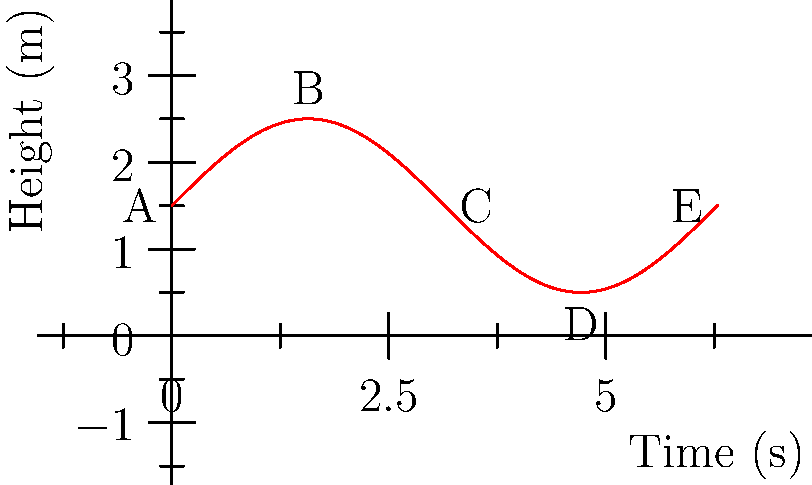In your ballet film, a dancer performs a series of fouetté turns. The graph shows the dancer's height above the stage during one complete turn, modeled by the function $h(t) = 1.5 + \sin(t)$, where $h$ is in meters and $t$ is in seconds. At what point during the turn is the dancer's vertical velocity the greatest, and what is this maximum velocity? To solve this, let's follow these steps:

1) The vertical velocity is given by the derivative of the height function:
   $v(t) = h'(t) = \frac{d}{dt}(1.5 + \sin(t)) = \cos(t)$

2) The maximum velocity occurs where the derivative of the velocity (acceleration) is zero:
   $a(t) = v'(t) = -\sin(t)$

3) Setting this equal to zero:
   $-\sin(t) = 0$
   $\sin(t) = 0$

4) This occurs when $t = 0, \pi, 2\pi, ...$

5) Looking at our original velocity function $v(t) = \cos(t)$, we see that:
   At $t = 0$, $v(0) = \cos(0) = 1$
   At $t = \pi$, $v(\pi) = \cos(\pi) = -1$

6) The absolute value is greatest at both these points, but the question asks for the greatest velocity, not speed.

7) Therefore, the maximum velocity occurs at $t = 0$, which corresponds to point A on the graph.

8) The maximum velocity is $1$ m/s upward.
Answer: At point A, with a maximum velocity of 1 m/s upward. 